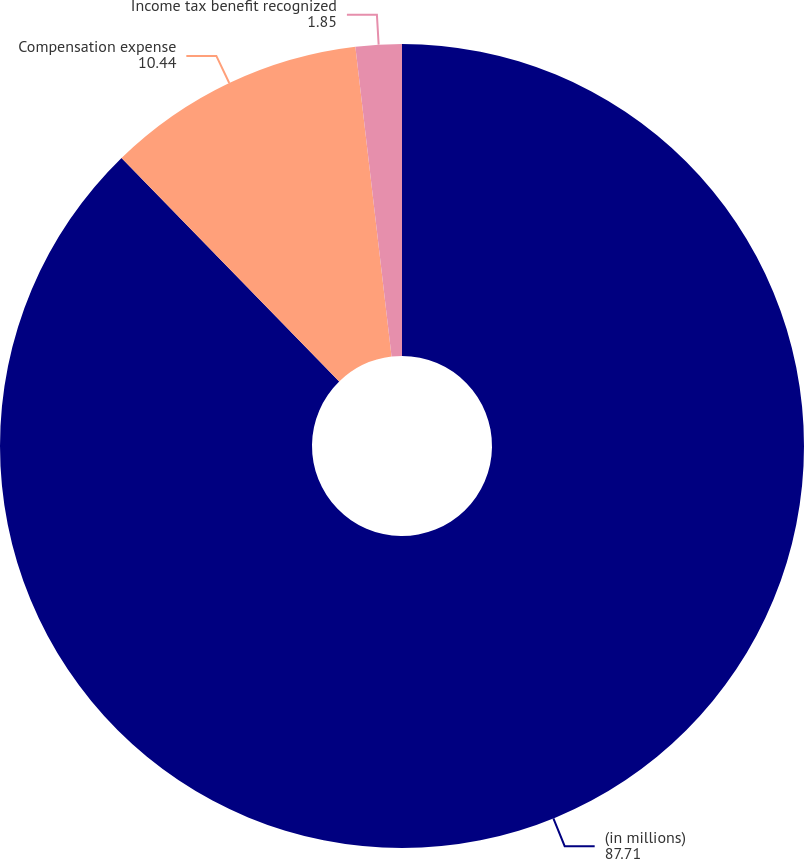<chart> <loc_0><loc_0><loc_500><loc_500><pie_chart><fcel>(in millions)<fcel>Compensation expense<fcel>Income tax benefit recognized<nl><fcel>87.71%<fcel>10.44%<fcel>1.85%<nl></chart> 